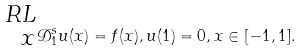<formula> <loc_0><loc_0><loc_500><loc_500>\prescript { R L } { x } { \mathcal { D } } _ { 1 } ^ { s } u ( x ) = f ( x ) , u { ( 1 ) } = 0 , x \in [ - 1 , 1 ] .</formula> 